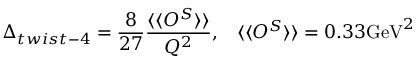Convert formula to latex. <formula><loc_0><loc_0><loc_500><loc_500>\Delta _ { t w i s t - 4 } = \frac { 8 } { 2 7 } \frac { \langle \langle O ^ { S } \rangle \rangle } { Q ^ { 2 } } , \, \langle \langle O ^ { S } \rangle \rangle = 0 . 3 3 G e V ^ { 2 }</formula> 